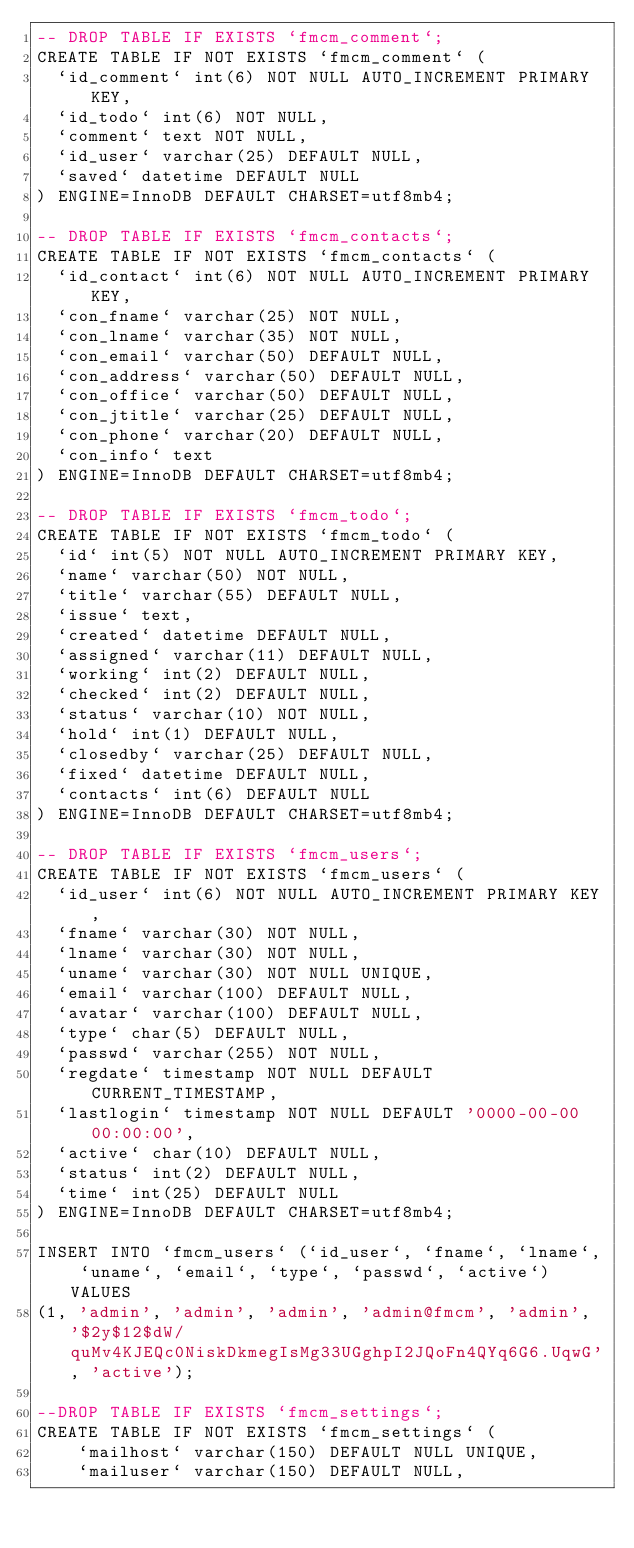<code> <loc_0><loc_0><loc_500><loc_500><_SQL_>-- DROP TABLE IF EXISTS `fmcm_comment`;
CREATE TABLE IF NOT EXISTS `fmcm_comment` (
  `id_comment` int(6) NOT NULL AUTO_INCREMENT PRIMARY KEY,
  `id_todo` int(6) NOT NULL,
  `comment` text NOT NULL,
  `id_user` varchar(25) DEFAULT NULL,
  `saved` datetime DEFAULT NULL
) ENGINE=InnoDB DEFAULT CHARSET=utf8mb4;

-- DROP TABLE IF EXISTS `fmcm_contacts`;
CREATE TABLE IF NOT EXISTS `fmcm_contacts` (
  `id_contact` int(6) NOT NULL AUTO_INCREMENT PRIMARY KEY,
  `con_fname` varchar(25) NOT NULL,
  `con_lname` varchar(35) NOT NULL,
  `con_email` varchar(50) DEFAULT NULL,
  `con_address` varchar(50) DEFAULT NULL,
  `con_office` varchar(50) DEFAULT NULL,
  `con_jtitle` varchar(25) DEFAULT NULL,
  `con_phone` varchar(20) DEFAULT NULL,
  `con_info` text
) ENGINE=InnoDB DEFAULT CHARSET=utf8mb4;

-- DROP TABLE IF EXISTS `fmcm_todo`;
CREATE TABLE IF NOT EXISTS `fmcm_todo` (
  `id` int(5) NOT NULL AUTO_INCREMENT PRIMARY KEY,
  `name` varchar(50) NOT NULL,
  `title` varchar(55) DEFAULT NULL,
  `issue` text,
  `created` datetime DEFAULT NULL,
  `assigned` varchar(11) DEFAULT NULL,
  `working` int(2) DEFAULT NULL,
  `checked` int(2) DEFAULT NULL,
  `status` varchar(10) NOT NULL,
  `hold` int(1) DEFAULT NULL,
  `closedby` varchar(25) DEFAULT NULL,
  `fixed` datetime DEFAULT NULL,
  `contacts` int(6) DEFAULT NULL
) ENGINE=InnoDB DEFAULT CHARSET=utf8mb4;

-- DROP TABLE IF EXISTS `fmcm_users`;
CREATE TABLE IF NOT EXISTS `fmcm_users` (
  `id_user` int(6) NOT NULL AUTO_INCREMENT PRIMARY KEY,
  `fname` varchar(30) NOT NULL,
  `lname` varchar(30) NOT NULL,
  `uname` varchar(30) NOT NULL UNIQUE,
  `email` varchar(100) DEFAULT NULL,
  `avatar` varchar(100) DEFAULT NULL,
  `type` char(5) DEFAULT NULL,
  `passwd` varchar(255) NOT NULL,
  `regdate` timestamp NOT NULL DEFAULT CURRENT_TIMESTAMP,
  `lastlogin` timestamp NOT NULL DEFAULT '0000-00-00 00:00:00',
  `active` char(10) DEFAULT NULL,
  `status` int(2) DEFAULT NULL,
  `time` int(25) DEFAULT NULL
) ENGINE=InnoDB DEFAULT CHARSET=utf8mb4;

INSERT INTO `fmcm_users` (`id_user`, `fname`, `lname`, `uname`, `email`, `type`, `passwd`, `active`) VALUES
(1, 'admin', 'admin', 'admin', 'admin@fmcm', 'admin', '$2y$12$dW/quMv4KJEQc0NiskDkmegIsMg33UGghpI2JQoFn4QYq6G6.UqwG', 'active');

--DROP TABLE IF EXISTS `fmcm_settings`;
CREATE TABLE IF NOT EXISTS `fmcm_settings` (
    `mailhost` varchar(150) DEFAULT NULL UNIQUE,
    `mailuser` varchar(150) DEFAULT NULL,</code> 